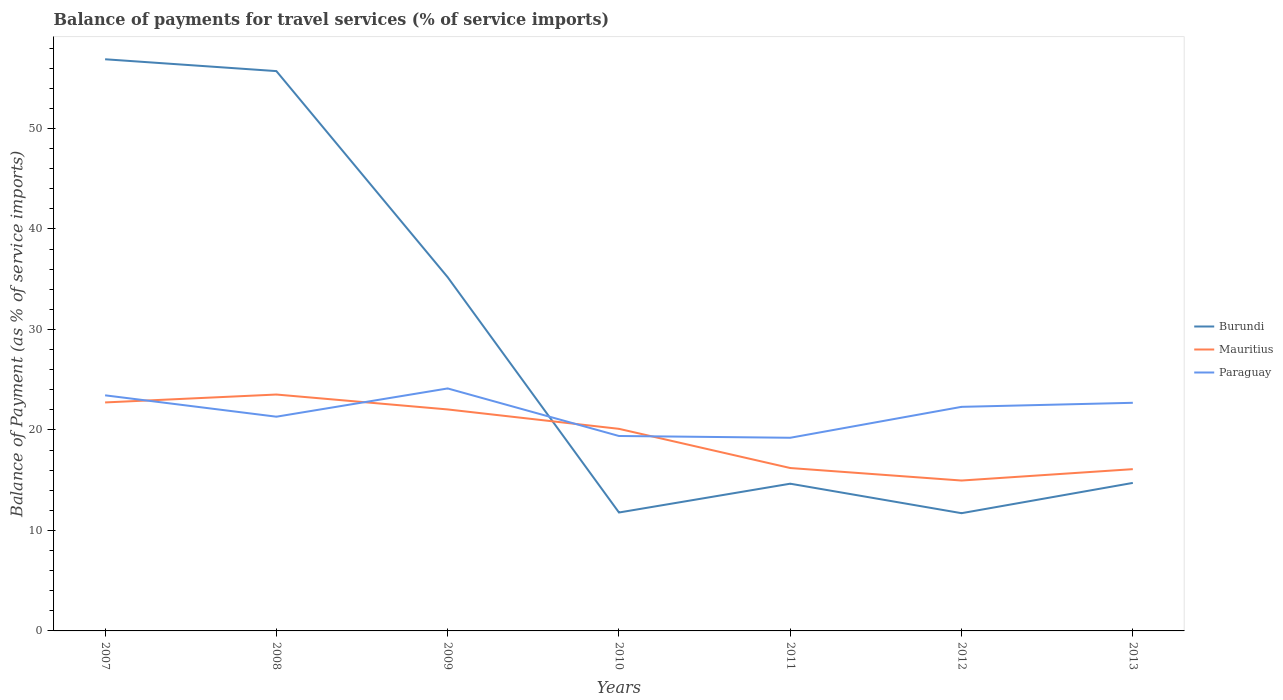How many different coloured lines are there?
Your response must be concise. 3. Across all years, what is the maximum balance of payments for travel services in Burundi?
Your response must be concise. 11.72. What is the total balance of payments for travel services in Paraguay in the graph?
Provide a succinct answer. -2.81. What is the difference between the highest and the second highest balance of payments for travel services in Mauritius?
Give a very brief answer. 8.56. Is the balance of payments for travel services in Mauritius strictly greater than the balance of payments for travel services in Paraguay over the years?
Your response must be concise. No. How many lines are there?
Your answer should be compact. 3. What is the difference between two consecutive major ticks on the Y-axis?
Make the answer very short. 10. Are the values on the major ticks of Y-axis written in scientific E-notation?
Offer a very short reply. No. How are the legend labels stacked?
Offer a very short reply. Vertical. What is the title of the graph?
Offer a very short reply. Balance of payments for travel services (% of service imports). What is the label or title of the X-axis?
Provide a succinct answer. Years. What is the label or title of the Y-axis?
Your answer should be compact. Balance of Payment (as % of service imports). What is the Balance of Payment (as % of service imports) of Burundi in 2007?
Make the answer very short. 56.89. What is the Balance of Payment (as % of service imports) in Mauritius in 2007?
Your response must be concise. 22.74. What is the Balance of Payment (as % of service imports) of Paraguay in 2007?
Offer a terse response. 23.45. What is the Balance of Payment (as % of service imports) in Burundi in 2008?
Provide a short and direct response. 55.71. What is the Balance of Payment (as % of service imports) in Mauritius in 2008?
Offer a terse response. 23.52. What is the Balance of Payment (as % of service imports) of Paraguay in 2008?
Give a very brief answer. 21.32. What is the Balance of Payment (as % of service imports) in Burundi in 2009?
Your response must be concise. 35.2. What is the Balance of Payment (as % of service imports) in Mauritius in 2009?
Ensure brevity in your answer.  22.04. What is the Balance of Payment (as % of service imports) in Paraguay in 2009?
Keep it short and to the point. 24.13. What is the Balance of Payment (as % of service imports) of Burundi in 2010?
Your answer should be compact. 11.79. What is the Balance of Payment (as % of service imports) of Mauritius in 2010?
Keep it short and to the point. 20.11. What is the Balance of Payment (as % of service imports) of Paraguay in 2010?
Provide a short and direct response. 19.4. What is the Balance of Payment (as % of service imports) of Burundi in 2011?
Give a very brief answer. 14.65. What is the Balance of Payment (as % of service imports) in Mauritius in 2011?
Ensure brevity in your answer.  16.21. What is the Balance of Payment (as % of service imports) of Paraguay in 2011?
Keep it short and to the point. 19.22. What is the Balance of Payment (as % of service imports) in Burundi in 2012?
Offer a terse response. 11.72. What is the Balance of Payment (as % of service imports) of Mauritius in 2012?
Provide a short and direct response. 14.97. What is the Balance of Payment (as % of service imports) in Paraguay in 2012?
Your answer should be compact. 22.3. What is the Balance of Payment (as % of service imports) in Burundi in 2013?
Offer a terse response. 14.73. What is the Balance of Payment (as % of service imports) of Mauritius in 2013?
Give a very brief answer. 16.1. What is the Balance of Payment (as % of service imports) in Paraguay in 2013?
Give a very brief answer. 22.7. Across all years, what is the maximum Balance of Payment (as % of service imports) of Burundi?
Your answer should be compact. 56.89. Across all years, what is the maximum Balance of Payment (as % of service imports) of Mauritius?
Give a very brief answer. 23.52. Across all years, what is the maximum Balance of Payment (as % of service imports) of Paraguay?
Keep it short and to the point. 24.13. Across all years, what is the minimum Balance of Payment (as % of service imports) of Burundi?
Offer a terse response. 11.72. Across all years, what is the minimum Balance of Payment (as % of service imports) of Mauritius?
Ensure brevity in your answer.  14.97. Across all years, what is the minimum Balance of Payment (as % of service imports) in Paraguay?
Make the answer very short. 19.22. What is the total Balance of Payment (as % of service imports) in Burundi in the graph?
Your answer should be compact. 200.68. What is the total Balance of Payment (as % of service imports) in Mauritius in the graph?
Make the answer very short. 135.69. What is the total Balance of Payment (as % of service imports) of Paraguay in the graph?
Keep it short and to the point. 152.52. What is the difference between the Balance of Payment (as % of service imports) of Burundi in 2007 and that in 2008?
Give a very brief answer. 1.18. What is the difference between the Balance of Payment (as % of service imports) in Mauritius in 2007 and that in 2008?
Your answer should be very brief. -0.79. What is the difference between the Balance of Payment (as % of service imports) of Paraguay in 2007 and that in 2008?
Keep it short and to the point. 2.13. What is the difference between the Balance of Payment (as % of service imports) in Burundi in 2007 and that in 2009?
Your answer should be compact. 21.69. What is the difference between the Balance of Payment (as % of service imports) of Mauritius in 2007 and that in 2009?
Give a very brief answer. 0.7. What is the difference between the Balance of Payment (as % of service imports) in Paraguay in 2007 and that in 2009?
Your answer should be compact. -0.68. What is the difference between the Balance of Payment (as % of service imports) of Burundi in 2007 and that in 2010?
Your response must be concise. 45.1. What is the difference between the Balance of Payment (as % of service imports) in Mauritius in 2007 and that in 2010?
Your response must be concise. 2.63. What is the difference between the Balance of Payment (as % of service imports) of Paraguay in 2007 and that in 2010?
Offer a very short reply. 4.05. What is the difference between the Balance of Payment (as % of service imports) in Burundi in 2007 and that in 2011?
Ensure brevity in your answer.  42.24. What is the difference between the Balance of Payment (as % of service imports) in Mauritius in 2007 and that in 2011?
Keep it short and to the point. 6.53. What is the difference between the Balance of Payment (as % of service imports) of Paraguay in 2007 and that in 2011?
Your answer should be very brief. 4.23. What is the difference between the Balance of Payment (as % of service imports) in Burundi in 2007 and that in 2012?
Offer a terse response. 45.17. What is the difference between the Balance of Payment (as % of service imports) in Mauritius in 2007 and that in 2012?
Give a very brief answer. 7.77. What is the difference between the Balance of Payment (as % of service imports) of Paraguay in 2007 and that in 2012?
Keep it short and to the point. 1.15. What is the difference between the Balance of Payment (as % of service imports) in Burundi in 2007 and that in 2013?
Provide a short and direct response. 42.16. What is the difference between the Balance of Payment (as % of service imports) in Mauritius in 2007 and that in 2013?
Make the answer very short. 6.64. What is the difference between the Balance of Payment (as % of service imports) in Paraguay in 2007 and that in 2013?
Your response must be concise. 0.74. What is the difference between the Balance of Payment (as % of service imports) of Burundi in 2008 and that in 2009?
Ensure brevity in your answer.  20.51. What is the difference between the Balance of Payment (as % of service imports) in Mauritius in 2008 and that in 2009?
Provide a short and direct response. 1.48. What is the difference between the Balance of Payment (as % of service imports) in Paraguay in 2008 and that in 2009?
Give a very brief answer. -2.81. What is the difference between the Balance of Payment (as % of service imports) of Burundi in 2008 and that in 2010?
Offer a terse response. 43.93. What is the difference between the Balance of Payment (as % of service imports) of Mauritius in 2008 and that in 2010?
Your response must be concise. 3.41. What is the difference between the Balance of Payment (as % of service imports) in Paraguay in 2008 and that in 2010?
Ensure brevity in your answer.  1.92. What is the difference between the Balance of Payment (as % of service imports) of Burundi in 2008 and that in 2011?
Ensure brevity in your answer.  41.06. What is the difference between the Balance of Payment (as % of service imports) of Mauritius in 2008 and that in 2011?
Your answer should be very brief. 7.31. What is the difference between the Balance of Payment (as % of service imports) in Paraguay in 2008 and that in 2011?
Give a very brief answer. 2.1. What is the difference between the Balance of Payment (as % of service imports) in Burundi in 2008 and that in 2012?
Offer a very short reply. 44. What is the difference between the Balance of Payment (as % of service imports) in Mauritius in 2008 and that in 2012?
Ensure brevity in your answer.  8.56. What is the difference between the Balance of Payment (as % of service imports) in Paraguay in 2008 and that in 2012?
Ensure brevity in your answer.  -0.98. What is the difference between the Balance of Payment (as % of service imports) of Burundi in 2008 and that in 2013?
Provide a short and direct response. 40.98. What is the difference between the Balance of Payment (as % of service imports) of Mauritius in 2008 and that in 2013?
Offer a terse response. 7.43. What is the difference between the Balance of Payment (as % of service imports) in Paraguay in 2008 and that in 2013?
Your answer should be very brief. -1.38. What is the difference between the Balance of Payment (as % of service imports) in Burundi in 2009 and that in 2010?
Make the answer very short. 23.42. What is the difference between the Balance of Payment (as % of service imports) of Mauritius in 2009 and that in 2010?
Your answer should be very brief. 1.93. What is the difference between the Balance of Payment (as % of service imports) of Paraguay in 2009 and that in 2010?
Provide a succinct answer. 4.73. What is the difference between the Balance of Payment (as % of service imports) of Burundi in 2009 and that in 2011?
Offer a very short reply. 20.55. What is the difference between the Balance of Payment (as % of service imports) of Mauritius in 2009 and that in 2011?
Offer a terse response. 5.83. What is the difference between the Balance of Payment (as % of service imports) in Paraguay in 2009 and that in 2011?
Your answer should be very brief. 4.91. What is the difference between the Balance of Payment (as % of service imports) of Burundi in 2009 and that in 2012?
Provide a succinct answer. 23.48. What is the difference between the Balance of Payment (as % of service imports) of Mauritius in 2009 and that in 2012?
Make the answer very short. 7.08. What is the difference between the Balance of Payment (as % of service imports) of Paraguay in 2009 and that in 2012?
Your answer should be very brief. 1.83. What is the difference between the Balance of Payment (as % of service imports) of Burundi in 2009 and that in 2013?
Offer a very short reply. 20.47. What is the difference between the Balance of Payment (as % of service imports) of Mauritius in 2009 and that in 2013?
Offer a very short reply. 5.94. What is the difference between the Balance of Payment (as % of service imports) in Paraguay in 2009 and that in 2013?
Keep it short and to the point. 1.43. What is the difference between the Balance of Payment (as % of service imports) of Burundi in 2010 and that in 2011?
Your answer should be very brief. -2.87. What is the difference between the Balance of Payment (as % of service imports) in Mauritius in 2010 and that in 2011?
Your response must be concise. 3.9. What is the difference between the Balance of Payment (as % of service imports) in Paraguay in 2010 and that in 2011?
Keep it short and to the point. 0.18. What is the difference between the Balance of Payment (as % of service imports) in Burundi in 2010 and that in 2012?
Make the answer very short. 0.07. What is the difference between the Balance of Payment (as % of service imports) in Mauritius in 2010 and that in 2012?
Provide a short and direct response. 5.15. What is the difference between the Balance of Payment (as % of service imports) of Paraguay in 2010 and that in 2012?
Make the answer very short. -2.9. What is the difference between the Balance of Payment (as % of service imports) in Burundi in 2010 and that in 2013?
Provide a short and direct response. -2.94. What is the difference between the Balance of Payment (as % of service imports) of Mauritius in 2010 and that in 2013?
Give a very brief answer. 4.01. What is the difference between the Balance of Payment (as % of service imports) in Paraguay in 2010 and that in 2013?
Offer a very short reply. -3.3. What is the difference between the Balance of Payment (as % of service imports) of Burundi in 2011 and that in 2012?
Your answer should be compact. 2.94. What is the difference between the Balance of Payment (as % of service imports) in Mauritius in 2011 and that in 2012?
Your answer should be very brief. 1.24. What is the difference between the Balance of Payment (as % of service imports) in Paraguay in 2011 and that in 2012?
Ensure brevity in your answer.  -3.08. What is the difference between the Balance of Payment (as % of service imports) in Burundi in 2011 and that in 2013?
Offer a terse response. -0.08. What is the difference between the Balance of Payment (as % of service imports) of Mauritius in 2011 and that in 2013?
Give a very brief answer. 0.11. What is the difference between the Balance of Payment (as % of service imports) of Paraguay in 2011 and that in 2013?
Keep it short and to the point. -3.48. What is the difference between the Balance of Payment (as % of service imports) of Burundi in 2012 and that in 2013?
Your answer should be compact. -3.01. What is the difference between the Balance of Payment (as % of service imports) of Mauritius in 2012 and that in 2013?
Your response must be concise. -1.13. What is the difference between the Balance of Payment (as % of service imports) of Paraguay in 2012 and that in 2013?
Offer a very short reply. -0.4. What is the difference between the Balance of Payment (as % of service imports) of Burundi in 2007 and the Balance of Payment (as % of service imports) of Mauritius in 2008?
Your answer should be compact. 33.36. What is the difference between the Balance of Payment (as % of service imports) of Burundi in 2007 and the Balance of Payment (as % of service imports) of Paraguay in 2008?
Provide a short and direct response. 35.57. What is the difference between the Balance of Payment (as % of service imports) of Mauritius in 2007 and the Balance of Payment (as % of service imports) of Paraguay in 2008?
Provide a short and direct response. 1.42. What is the difference between the Balance of Payment (as % of service imports) of Burundi in 2007 and the Balance of Payment (as % of service imports) of Mauritius in 2009?
Offer a terse response. 34.85. What is the difference between the Balance of Payment (as % of service imports) in Burundi in 2007 and the Balance of Payment (as % of service imports) in Paraguay in 2009?
Your answer should be compact. 32.76. What is the difference between the Balance of Payment (as % of service imports) in Mauritius in 2007 and the Balance of Payment (as % of service imports) in Paraguay in 2009?
Your response must be concise. -1.39. What is the difference between the Balance of Payment (as % of service imports) in Burundi in 2007 and the Balance of Payment (as % of service imports) in Mauritius in 2010?
Offer a terse response. 36.78. What is the difference between the Balance of Payment (as % of service imports) of Burundi in 2007 and the Balance of Payment (as % of service imports) of Paraguay in 2010?
Provide a succinct answer. 37.49. What is the difference between the Balance of Payment (as % of service imports) in Mauritius in 2007 and the Balance of Payment (as % of service imports) in Paraguay in 2010?
Your response must be concise. 3.34. What is the difference between the Balance of Payment (as % of service imports) of Burundi in 2007 and the Balance of Payment (as % of service imports) of Mauritius in 2011?
Your answer should be compact. 40.68. What is the difference between the Balance of Payment (as % of service imports) of Burundi in 2007 and the Balance of Payment (as % of service imports) of Paraguay in 2011?
Give a very brief answer. 37.67. What is the difference between the Balance of Payment (as % of service imports) in Mauritius in 2007 and the Balance of Payment (as % of service imports) in Paraguay in 2011?
Ensure brevity in your answer.  3.52. What is the difference between the Balance of Payment (as % of service imports) of Burundi in 2007 and the Balance of Payment (as % of service imports) of Mauritius in 2012?
Provide a succinct answer. 41.92. What is the difference between the Balance of Payment (as % of service imports) in Burundi in 2007 and the Balance of Payment (as % of service imports) in Paraguay in 2012?
Give a very brief answer. 34.59. What is the difference between the Balance of Payment (as % of service imports) of Mauritius in 2007 and the Balance of Payment (as % of service imports) of Paraguay in 2012?
Provide a succinct answer. 0.44. What is the difference between the Balance of Payment (as % of service imports) of Burundi in 2007 and the Balance of Payment (as % of service imports) of Mauritius in 2013?
Keep it short and to the point. 40.79. What is the difference between the Balance of Payment (as % of service imports) of Burundi in 2007 and the Balance of Payment (as % of service imports) of Paraguay in 2013?
Give a very brief answer. 34.19. What is the difference between the Balance of Payment (as % of service imports) of Mauritius in 2007 and the Balance of Payment (as % of service imports) of Paraguay in 2013?
Offer a very short reply. 0.04. What is the difference between the Balance of Payment (as % of service imports) in Burundi in 2008 and the Balance of Payment (as % of service imports) in Mauritius in 2009?
Your answer should be very brief. 33.67. What is the difference between the Balance of Payment (as % of service imports) of Burundi in 2008 and the Balance of Payment (as % of service imports) of Paraguay in 2009?
Your response must be concise. 31.58. What is the difference between the Balance of Payment (as % of service imports) in Mauritius in 2008 and the Balance of Payment (as % of service imports) in Paraguay in 2009?
Make the answer very short. -0.61. What is the difference between the Balance of Payment (as % of service imports) of Burundi in 2008 and the Balance of Payment (as % of service imports) of Mauritius in 2010?
Give a very brief answer. 35.6. What is the difference between the Balance of Payment (as % of service imports) of Burundi in 2008 and the Balance of Payment (as % of service imports) of Paraguay in 2010?
Give a very brief answer. 36.31. What is the difference between the Balance of Payment (as % of service imports) of Mauritius in 2008 and the Balance of Payment (as % of service imports) of Paraguay in 2010?
Ensure brevity in your answer.  4.13. What is the difference between the Balance of Payment (as % of service imports) of Burundi in 2008 and the Balance of Payment (as % of service imports) of Mauritius in 2011?
Offer a very short reply. 39.5. What is the difference between the Balance of Payment (as % of service imports) of Burundi in 2008 and the Balance of Payment (as % of service imports) of Paraguay in 2011?
Provide a short and direct response. 36.49. What is the difference between the Balance of Payment (as % of service imports) in Mauritius in 2008 and the Balance of Payment (as % of service imports) in Paraguay in 2011?
Offer a terse response. 4.3. What is the difference between the Balance of Payment (as % of service imports) in Burundi in 2008 and the Balance of Payment (as % of service imports) in Mauritius in 2012?
Offer a very short reply. 40.75. What is the difference between the Balance of Payment (as % of service imports) of Burundi in 2008 and the Balance of Payment (as % of service imports) of Paraguay in 2012?
Your answer should be very brief. 33.41. What is the difference between the Balance of Payment (as % of service imports) in Mauritius in 2008 and the Balance of Payment (as % of service imports) in Paraguay in 2012?
Your answer should be compact. 1.22. What is the difference between the Balance of Payment (as % of service imports) in Burundi in 2008 and the Balance of Payment (as % of service imports) in Mauritius in 2013?
Offer a terse response. 39.61. What is the difference between the Balance of Payment (as % of service imports) of Burundi in 2008 and the Balance of Payment (as % of service imports) of Paraguay in 2013?
Your answer should be very brief. 33.01. What is the difference between the Balance of Payment (as % of service imports) of Mauritius in 2008 and the Balance of Payment (as % of service imports) of Paraguay in 2013?
Offer a very short reply. 0.82. What is the difference between the Balance of Payment (as % of service imports) in Burundi in 2009 and the Balance of Payment (as % of service imports) in Mauritius in 2010?
Your answer should be very brief. 15.09. What is the difference between the Balance of Payment (as % of service imports) in Burundi in 2009 and the Balance of Payment (as % of service imports) in Paraguay in 2010?
Give a very brief answer. 15.8. What is the difference between the Balance of Payment (as % of service imports) in Mauritius in 2009 and the Balance of Payment (as % of service imports) in Paraguay in 2010?
Your answer should be very brief. 2.64. What is the difference between the Balance of Payment (as % of service imports) of Burundi in 2009 and the Balance of Payment (as % of service imports) of Mauritius in 2011?
Ensure brevity in your answer.  18.99. What is the difference between the Balance of Payment (as % of service imports) of Burundi in 2009 and the Balance of Payment (as % of service imports) of Paraguay in 2011?
Your answer should be compact. 15.98. What is the difference between the Balance of Payment (as % of service imports) in Mauritius in 2009 and the Balance of Payment (as % of service imports) in Paraguay in 2011?
Give a very brief answer. 2.82. What is the difference between the Balance of Payment (as % of service imports) in Burundi in 2009 and the Balance of Payment (as % of service imports) in Mauritius in 2012?
Make the answer very short. 20.23. What is the difference between the Balance of Payment (as % of service imports) of Burundi in 2009 and the Balance of Payment (as % of service imports) of Paraguay in 2012?
Give a very brief answer. 12.9. What is the difference between the Balance of Payment (as % of service imports) in Mauritius in 2009 and the Balance of Payment (as % of service imports) in Paraguay in 2012?
Provide a succinct answer. -0.26. What is the difference between the Balance of Payment (as % of service imports) in Burundi in 2009 and the Balance of Payment (as % of service imports) in Mauritius in 2013?
Keep it short and to the point. 19.1. What is the difference between the Balance of Payment (as % of service imports) in Burundi in 2009 and the Balance of Payment (as % of service imports) in Paraguay in 2013?
Your response must be concise. 12.5. What is the difference between the Balance of Payment (as % of service imports) in Mauritius in 2009 and the Balance of Payment (as % of service imports) in Paraguay in 2013?
Keep it short and to the point. -0.66. What is the difference between the Balance of Payment (as % of service imports) of Burundi in 2010 and the Balance of Payment (as % of service imports) of Mauritius in 2011?
Make the answer very short. -4.43. What is the difference between the Balance of Payment (as % of service imports) of Burundi in 2010 and the Balance of Payment (as % of service imports) of Paraguay in 2011?
Ensure brevity in your answer.  -7.44. What is the difference between the Balance of Payment (as % of service imports) of Mauritius in 2010 and the Balance of Payment (as % of service imports) of Paraguay in 2011?
Offer a very short reply. 0.89. What is the difference between the Balance of Payment (as % of service imports) of Burundi in 2010 and the Balance of Payment (as % of service imports) of Mauritius in 2012?
Offer a very short reply. -3.18. What is the difference between the Balance of Payment (as % of service imports) of Burundi in 2010 and the Balance of Payment (as % of service imports) of Paraguay in 2012?
Ensure brevity in your answer.  -10.51. What is the difference between the Balance of Payment (as % of service imports) of Mauritius in 2010 and the Balance of Payment (as % of service imports) of Paraguay in 2012?
Give a very brief answer. -2.19. What is the difference between the Balance of Payment (as % of service imports) in Burundi in 2010 and the Balance of Payment (as % of service imports) in Mauritius in 2013?
Offer a terse response. -4.31. What is the difference between the Balance of Payment (as % of service imports) in Burundi in 2010 and the Balance of Payment (as % of service imports) in Paraguay in 2013?
Provide a short and direct response. -10.92. What is the difference between the Balance of Payment (as % of service imports) in Mauritius in 2010 and the Balance of Payment (as % of service imports) in Paraguay in 2013?
Your answer should be very brief. -2.59. What is the difference between the Balance of Payment (as % of service imports) of Burundi in 2011 and the Balance of Payment (as % of service imports) of Mauritius in 2012?
Keep it short and to the point. -0.31. What is the difference between the Balance of Payment (as % of service imports) of Burundi in 2011 and the Balance of Payment (as % of service imports) of Paraguay in 2012?
Your answer should be very brief. -7.65. What is the difference between the Balance of Payment (as % of service imports) of Mauritius in 2011 and the Balance of Payment (as % of service imports) of Paraguay in 2012?
Your answer should be very brief. -6.09. What is the difference between the Balance of Payment (as % of service imports) in Burundi in 2011 and the Balance of Payment (as % of service imports) in Mauritius in 2013?
Provide a short and direct response. -1.45. What is the difference between the Balance of Payment (as % of service imports) of Burundi in 2011 and the Balance of Payment (as % of service imports) of Paraguay in 2013?
Make the answer very short. -8.05. What is the difference between the Balance of Payment (as % of service imports) in Mauritius in 2011 and the Balance of Payment (as % of service imports) in Paraguay in 2013?
Keep it short and to the point. -6.49. What is the difference between the Balance of Payment (as % of service imports) in Burundi in 2012 and the Balance of Payment (as % of service imports) in Mauritius in 2013?
Your answer should be very brief. -4.38. What is the difference between the Balance of Payment (as % of service imports) of Burundi in 2012 and the Balance of Payment (as % of service imports) of Paraguay in 2013?
Your answer should be very brief. -10.99. What is the difference between the Balance of Payment (as % of service imports) of Mauritius in 2012 and the Balance of Payment (as % of service imports) of Paraguay in 2013?
Provide a short and direct response. -7.74. What is the average Balance of Payment (as % of service imports) of Burundi per year?
Offer a terse response. 28.67. What is the average Balance of Payment (as % of service imports) in Mauritius per year?
Offer a terse response. 19.38. What is the average Balance of Payment (as % of service imports) of Paraguay per year?
Your response must be concise. 21.79. In the year 2007, what is the difference between the Balance of Payment (as % of service imports) in Burundi and Balance of Payment (as % of service imports) in Mauritius?
Provide a short and direct response. 34.15. In the year 2007, what is the difference between the Balance of Payment (as % of service imports) of Burundi and Balance of Payment (as % of service imports) of Paraguay?
Give a very brief answer. 33.44. In the year 2007, what is the difference between the Balance of Payment (as % of service imports) in Mauritius and Balance of Payment (as % of service imports) in Paraguay?
Your answer should be compact. -0.71. In the year 2008, what is the difference between the Balance of Payment (as % of service imports) of Burundi and Balance of Payment (as % of service imports) of Mauritius?
Keep it short and to the point. 32.19. In the year 2008, what is the difference between the Balance of Payment (as % of service imports) of Burundi and Balance of Payment (as % of service imports) of Paraguay?
Provide a succinct answer. 34.39. In the year 2008, what is the difference between the Balance of Payment (as % of service imports) in Mauritius and Balance of Payment (as % of service imports) in Paraguay?
Give a very brief answer. 2.21. In the year 2009, what is the difference between the Balance of Payment (as % of service imports) in Burundi and Balance of Payment (as % of service imports) in Mauritius?
Make the answer very short. 13.16. In the year 2009, what is the difference between the Balance of Payment (as % of service imports) of Burundi and Balance of Payment (as % of service imports) of Paraguay?
Give a very brief answer. 11.07. In the year 2009, what is the difference between the Balance of Payment (as % of service imports) of Mauritius and Balance of Payment (as % of service imports) of Paraguay?
Give a very brief answer. -2.09. In the year 2010, what is the difference between the Balance of Payment (as % of service imports) of Burundi and Balance of Payment (as % of service imports) of Mauritius?
Ensure brevity in your answer.  -8.33. In the year 2010, what is the difference between the Balance of Payment (as % of service imports) in Burundi and Balance of Payment (as % of service imports) in Paraguay?
Offer a terse response. -7.61. In the year 2010, what is the difference between the Balance of Payment (as % of service imports) in Mauritius and Balance of Payment (as % of service imports) in Paraguay?
Offer a terse response. 0.71. In the year 2011, what is the difference between the Balance of Payment (as % of service imports) in Burundi and Balance of Payment (as % of service imports) in Mauritius?
Your response must be concise. -1.56. In the year 2011, what is the difference between the Balance of Payment (as % of service imports) in Burundi and Balance of Payment (as % of service imports) in Paraguay?
Offer a terse response. -4.57. In the year 2011, what is the difference between the Balance of Payment (as % of service imports) in Mauritius and Balance of Payment (as % of service imports) in Paraguay?
Your answer should be very brief. -3.01. In the year 2012, what is the difference between the Balance of Payment (as % of service imports) in Burundi and Balance of Payment (as % of service imports) in Mauritius?
Offer a terse response. -3.25. In the year 2012, what is the difference between the Balance of Payment (as % of service imports) of Burundi and Balance of Payment (as % of service imports) of Paraguay?
Your response must be concise. -10.58. In the year 2012, what is the difference between the Balance of Payment (as % of service imports) of Mauritius and Balance of Payment (as % of service imports) of Paraguay?
Make the answer very short. -7.33. In the year 2013, what is the difference between the Balance of Payment (as % of service imports) of Burundi and Balance of Payment (as % of service imports) of Mauritius?
Give a very brief answer. -1.37. In the year 2013, what is the difference between the Balance of Payment (as % of service imports) in Burundi and Balance of Payment (as % of service imports) in Paraguay?
Your response must be concise. -7.97. In the year 2013, what is the difference between the Balance of Payment (as % of service imports) in Mauritius and Balance of Payment (as % of service imports) in Paraguay?
Ensure brevity in your answer.  -6.6. What is the ratio of the Balance of Payment (as % of service imports) of Burundi in 2007 to that in 2008?
Provide a short and direct response. 1.02. What is the ratio of the Balance of Payment (as % of service imports) in Mauritius in 2007 to that in 2008?
Make the answer very short. 0.97. What is the ratio of the Balance of Payment (as % of service imports) of Paraguay in 2007 to that in 2008?
Offer a terse response. 1.1. What is the ratio of the Balance of Payment (as % of service imports) in Burundi in 2007 to that in 2009?
Make the answer very short. 1.62. What is the ratio of the Balance of Payment (as % of service imports) of Mauritius in 2007 to that in 2009?
Your answer should be very brief. 1.03. What is the ratio of the Balance of Payment (as % of service imports) in Paraguay in 2007 to that in 2009?
Provide a succinct answer. 0.97. What is the ratio of the Balance of Payment (as % of service imports) in Burundi in 2007 to that in 2010?
Keep it short and to the point. 4.83. What is the ratio of the Balance of Payment (as % of service imports) in Mauritius in 2007 to that in 2010?
Provide a succinct answer. 1.13. What is the ratio of the Balance of Payment (as % of service imports) of Paraguay in 2007 to that in 2010?
Give a very brief answer. 1.21. What is the ratio of the Balance of Payment (as % of service imports) of Burundi in 2007 to that in 2011?
Ensure brevity in your answer.  3.88. What is the ratio of the Balance of Payment (as % of service imports) of Mauritius in 2007 to that in 2011?
Provide a short and direct response. 1.4. What is the ratio of the Balance of Payment (as % of service imports) in Paraguay in 2007 to that in 2011?
Provide a succinct answer. 1.22. What is the ratio of the Balance of Payment (as % of service imports) of Burundi in 2007 to that in 2012?
Keep it short and to the point. 4.86. What is the ratio of the Balance of Payment (as % of service imports) of Mauritius in 2007 to that in 2012?
Offer a terse response. 1.52. What is the ratio of the Balance of Payment (as % of service imports) in Paraguay in 2007 to that in 2012?
Your answer should be very brief. 1.05. What is the ratio of the Balance of Payment (as % of service imports) in Burundi in 2007 to that in 2013?
Your answer should be compact. 3.86. What is the ratio of the Balance of Payment (as % of service imports) in Mauritius in 2007 to that in 2013?
Keep it short and to the point. 1.41. What is the ratio of the Balance of Payment (as % of service imports) of Paraguay in 2007 to that in 2013?
Your answer should be compact. 1.03. What is the ratio of the Balance of Payment (as % of service imports) in Burundi in 2008 to that in 2009?
Make the answer very short. 1.58. What is the ratio of the Balance of Payment (as % of service imports) of Mauritius in 2008 to that in 2009?
Give a very brief answer. 1.07. What is the ratio of the Balance of Payment (as % of service imports) in Paraguay in 2008 to that in 2009?
Provide a short and direct response. 0.88. What is the ratio of the Balance of Payment (as % of service imports) in Burundi in 2008 to that in 2010?
Your response must be concise. 4.73. What is the ratio of the Balance of Payment (as % of service imports) in Mauritius in 2008 to that in 2010?
Offer a terse response. 1.17. What is the ratio of the Balance of Payment (as % of service imports) of Paraguay in 2008 to that in 2010?
Offer a very short reply. 1.1. What is the ratio of the Balance of Payment (as % of service imports) in Burundi in 2008 to that in 2011?
Offer a very short reply. 3.8. What is the ratio of the Balance of Payment (as % of service imports) of Mauritius in 2008 to that in 2011?
Keep it short and to the point. 1.45. What is the ratio of the Balance of Payment (as % of service imports) in Paraguay in 2008 to that in 2011?
Your answer should be very brief. 1.11. What is the ratio of the Balance of Payment (as % of service imports) in Burundi in 2008 to that in 2012?
Keep it short and to the point. 4.75. What is the ratio of the Balance of Payment (as % of service imports) of Mauritius in 2008 to that in 2012?
Offer a very short reply. 1.57. What is the ratio of the Balance of Payment (as % of service imports) in Paraguay in 2008 to that in 2012?
Offer a terse response. 0.96. What is the ratio of the Balance of Payment (as % of service imports) of Burundi in 2008 to that in 2013?
Your response must be concise. 3.78. What is the ratio of the Balance of Payment (as % of service imports) in Mauritius in 2008 to that in 2013?
Give a very brief answer. 1.46. What is the ratio of the Balance of Payment (as % of service imports) of Paraguay in 2008 to that in 2013?
Make the answer very short. 0.94. What is the ratio of the Balance of Payment (as % of service imports) in Burundi in 2009 to that in 2010?
Offer a terse response. 2.99. What is the ratio of the Balance of Payment (as % of service imports) in Mauritius in 2009 to that in 2010?
Give a very brief answer. 1.1. What is the ratio of the Balance of Payment (as % of service imports) in Paraguay in 2009 to that in 2010?
Your answer should be compact. 1.24. What is the ratio of the Balance of Payment (as % of service imports) of Burundi in 2009 to that in 2011?
Keep it short and to the point. 2.4. What is the ratio of the Balance of Payment (as % of service imports) of Mauritius in 2009 to that in 2011?
Your answer should be compact. 1.36. What is the ratio of the Balance of Payment (as % of service imports) of Paraguay in 2009 to that in 2011?
Provide a short and direct response. 1.26. What is the ratio of the Balance of Payment (as % of service imports) in Burundi in 2009 to that in 2012?
Your answer should be very brief. 3. What is the ratio of the Balance of Payment (as % of service imports) in Mauritius in 2009 to that in 2012?
Make the answer very short. 1.47. What is the ratio of the Balance of Payment (as % of service imports) of Paraguay in 2009 to that in 2012?
Ensure brevity in your answer.  1.08. What is the ratio of the Balance of Payment (as % of service imports) of Burundi in 2009 to that in 2013?
Offer a very short reply. 2.39. What is the ratio of the Balance of Payment (as % of service imports) in Mauritius in 2009 to that in 2013?
Offer a very short reply. 1.37. What is the ratio of the Balance of Payment (as % of service imports) in Paraguay in 2009 to that in 2013?
Your response must be concise. 1.06. What is the ratio of the Balance of Payment (as % of service imports) in Burundi in 2010 to that in 2011?
Provide a succinct answer. 0.8. What is the ratio of the Balance of Payment (as % of service imports) of Mauritius in 2010 to that in 2011?
Provide a succinct answer. 1.24. What is the ratio of the Balance of Payment (as % of service imports) of Paraguay in 2010 to that in 2011?
Your answer should be compact. 1.01. What is the ratio of the Balance of Payment (as % of service imports) of Burundi in 2010 to that in 2012?
Your answer should be very brief. 1.01. What is the ratio of the Balance of Payment (as % of service imports) of Mauritius in 2010 to that in 2012?
Your response must be concise. 1.34. What is the ratio of the Balance of Payment (as % of service imports) in Paraguay in 2010 to that in 2012?
Give a very brief answer. 0.87. What is the ratio of the Balance of Payment (as % of service imports) of Burundi in 2010 to that in 2013?
Provide a short and direct response. 0.8. What is the ratio of the Balance of Payment (as % of service imports) in Mauritius in 2010 to that in 2013?
Provide a succinct answer. 1.25. What is the ratio of the Balance of Payment (as % of service imports) in Paraguay in 2010 to that in 2013?
Your answer should be compact. 0.85. What is the ratio of the Balance of Payment (as % of service imports) in Burundi in 2011 to that in 2012?
Your answer should be compact. 1.25. What is the ratio of the Balance of Payment (as % of service imports) of Mauritius in 2011 to that in 2012?
Give a very brief answer. 1.08. What is the ratio of the Balance of Payment (as % of service imports) in Paraguay in 2011 to that in 2012?
Offer a terse response. 0.86. What is the ratio of the Balance of Payment (as % of service imports) of Mauritius in 2011 to that in 2013?
Ensure brevity in your answer.  1.01. What is the ratio of the Balance of Payment (as % of service imports) of Paraguay in 2011 to that in 2013?
Your response must be concise. 0.85. What is the ratio of the Balance of Payment (as % of service imports) in Burundi in 2012 to that in 2013?
Make the answer very short. 0.8. What is the ratio of the Balance of Payment (as % of service imports) of Mauritius in 2012 to that in 2013?
Your answer should be compact. 0.93. What is the ratio of the Balance of Payment (as % of service imports) of Paraguay in 2012 to that in 2013?
Offer a very short reply. 0.98. What is the difference between the highest and the second highest Balance of Payment (as % of service imports) of Burundi?
Give a very brief answer. 1.18. What is the difference between the highest and the second highest Balance of Payment (as % of service imports) in Mauritius?
Ensure brevity in your answer.  0.79. What is the difference between the highest and the second highest Balance of Payment (as % of service imports) in Paraguay?
Give a very brief answer. 0.68. What is the difference between the highest and the lowest Balance of Payment (as % of service imports) of Burundi?
Provide a succinct answer. 45.17. What is the difference between the highest and the lowest Balance of Payment (as % of service imports) in Mauritius?
Provide a succinct answer. 8.56. What is the difference between the highest and the lowest Balance of Payment (as % of service imports) of Paraguay?
Your answer should be compact. 4.91. 